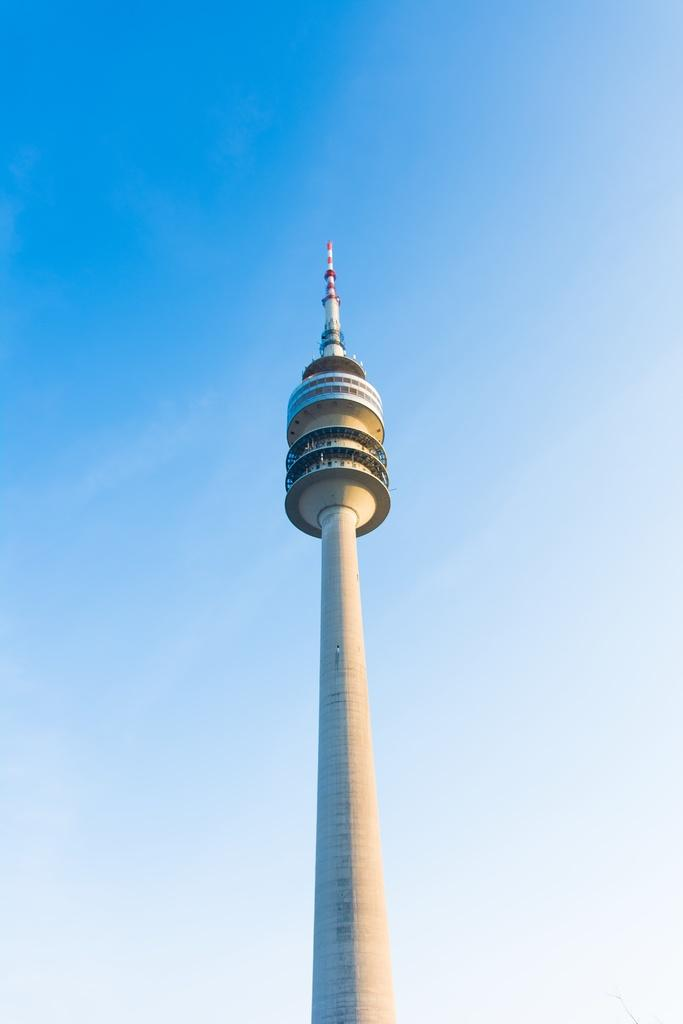What is the main subject of the image? The main subject of the image is a tower. Where is the tower located in the image? The tower is in the center of the image. What can be seen in the background of the image? Sky is visible in the background of the image. How many giraffes can be seen grazing in the foreground of the image? There are no giraffes present in the image; it features a tower with sky in the background. 